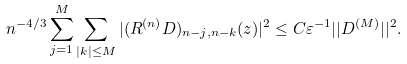<formula> <loc_0><loc_0><loc_500><loc_500>n ^ { - 4 / 3 } \sum _ { j = 1 } ^ { M } \sum _ { | k | \leq M } | ( R ^ { ( n ) } D ) _ { n - j , n - k } ( z ) | ^ { 2 } \leq C \varepsilon ^ { - 1 } | | D ^ { ( M ) } | | ^ { 2 } .</formula> 